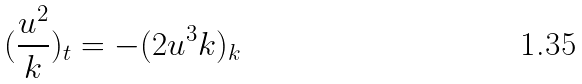Convert formula to latex. <formula><loc_0><loc_0><loc_500><loc_500>( { \frac { u ^ { 2 } } { k } } ) _ { t } = - ( 2 u ^ { 3 } k ) _ { k }</formula> 